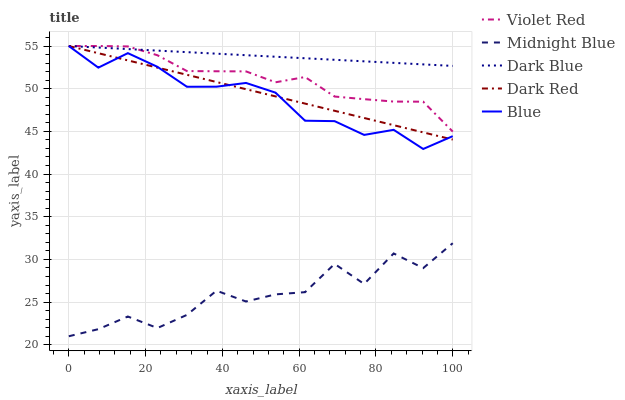Does Midnight Blue have the minimum area under the curve?
Answer yes or no. Yes. Does Dark Blue have the maximum area under the curve?
Answer yes or no. Yes. Does Violet Red have the minimum area under the curve?
Answer yes or no. No. Does Violet Red have the maximum area under the curve?
Answer yes or no. No. Is Dark Blue the smoothest?
Answer yes or no. Yes. Is Midnight Blue the roughest?
Answer yes or no. Yes. Is Violet Red the smoothest?
Answer yes or no. No. Is Violet Red the roughest?
Answer yes or no. No. Does Midnight Blue have the lowest value?
Answer yes or no. Yes. Does Violet Red have the lowest value?
Answer yes or no. No. Does Dark Red have the highest value?
Answer yes or no. Yes. Does Midnight Blue have the highest value?
Answer yes or no. No. Is Midnight Blue less than Dark Blue?
Answer yes or no. Yes. Is Dark Blue greater than Midnight Blue?
Answer yes or no. Yes. Does Violet Red intersect Dark Blue?
Answer yes or no. Yes. Is Violet Red less than Dark Blue?
Answer yes or no. No. Is Violet Red greater than Dark Blue?
Answer yes or no. No. Does Midnight Blue intersect Dark Blue?
Answer yes or no. No. 